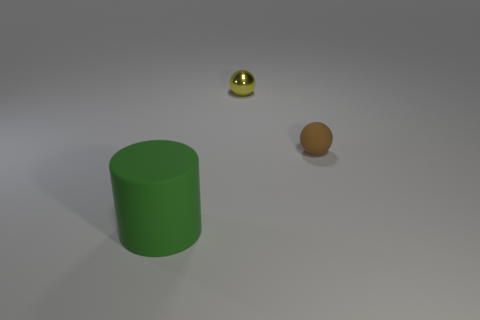Add 3 rubber cylinders. How many objects exist? 6 Subtract 1 cylinders. How many cylinders are left? 0 Subtract all brown spheres. How many spheres are left? 1 Subtract all red cylinders. How many green balls are left? 0 Subtract all spheres. How many objects are left? 1 Subtract all cyan balls. Subtract all cyan blocks. How many balls are left? 2 Subtract all red rubber cylinders. Subtract all big green rubber cylinders. How many objects are left? 2 Add 2 tiny yellow shiny things. How many tiny yellow shiny things are left? 3 Add 3 big yellow cylinders. How many big yellow cylinders exist? 3 Subtract 0 gray cylinders. How many objects are left? 3 